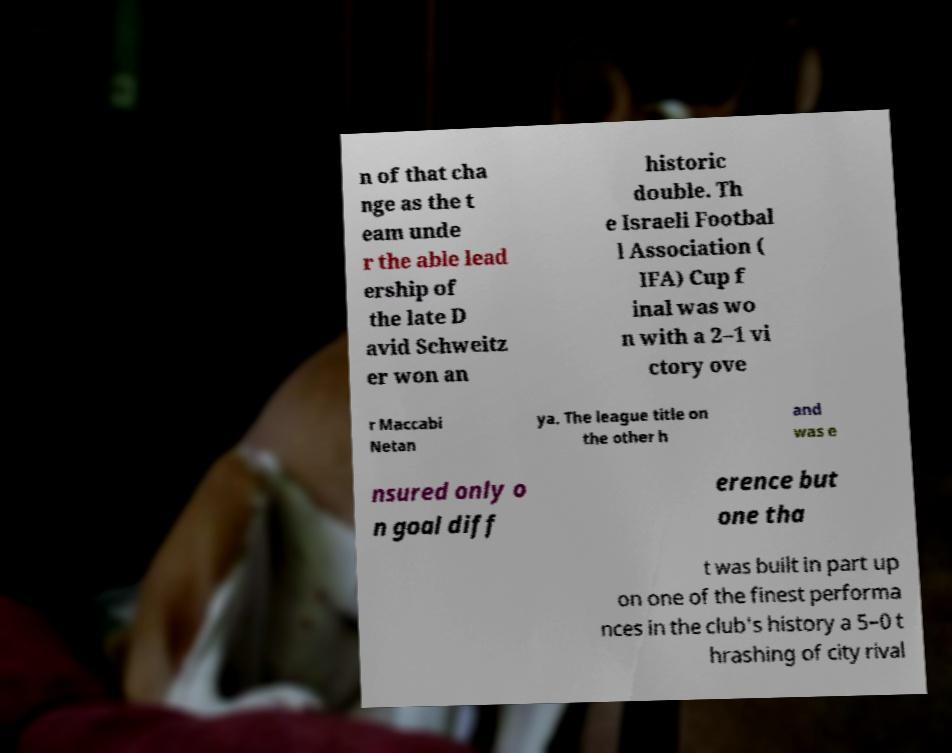Could you extract and type out the text from this image? n of that cha nge as the t eam unde r the able lead ership of the late D avid Schweitz er won an historic double. Th e Israeli Footbal l Association ( IFA) Cup f inal was wo n with a 2–1 vi ctory ove r Maccabi Netan ya. The league title on the other h and was e nsured only o n goal diff erence but one tha t was built in part up on one of the finest performa nces in the club's history a 5–0 t hrashing of city rival 